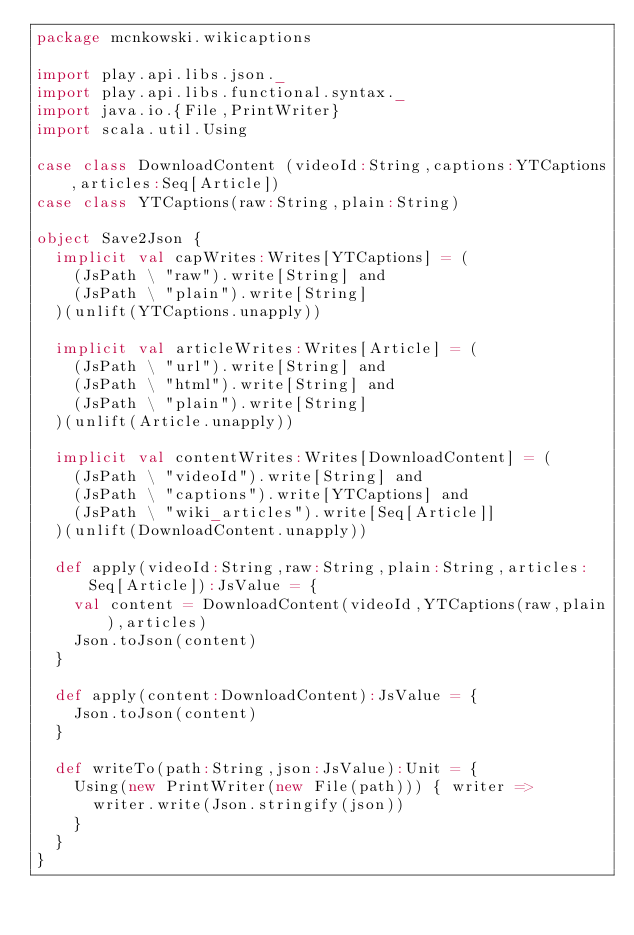Convert code to text. <code><loc_0><loc_0><loc_500><loc_500><_Scala_>package mcnkowski.wikicaptions

import play.api.libs.json._
import play.api.libs.functional.syntax._
import java.io.{File,PrintWriter}
import scala.util.Using

case class DownloadContent (videoId:String,captions:YTCaptions,articles:Seq[Article])
case class YTCaptions(raw:String,plain:String)

object Save2Json {
  implicit val capWrites:Writes[YTCaptions] = (
    (JsPath \ "raw").write[String] and
    (JsPath \ "plain").write[String]
  )(unlift(YTCaptions.unapply))

  implicit val articleWrites:Writes[Article] = (
    (JsPath \ "url").write[String] and
    (JsPath \ "html").write[String] and
    (JsPath \ "plain").write[String]
  )(unlift(Article.unapply))

  implicit val contentWrites:Writes[DownloadContent] = (
    (JsPath \ "videoId").write[String] and
    (JsPath \ "captions").write[YTCaptions] and
    (JsPath \ "wiki_articles").write[Seq[Article]]
  )(unlift(DownloadContent.unapply))
  
  def apply(videoId:String,raw:String,plain:String,articles:Seq[Article]):JsValue = {
    val content = DownloadContent(videoId,YTCaptions(raw,plain),articles)
    Json.toJson(content)
  }
  
  def apply(content:DownloadContent):JsValue = {
    Json.toJson(content)
  }
  
  def writeTo(path:String,json:JsValue):Unit = {
    Using(new PrintWriter(new File(path))) { writer =>
      writer.write(Json.stringify(json))
    }
  }
}</code> 